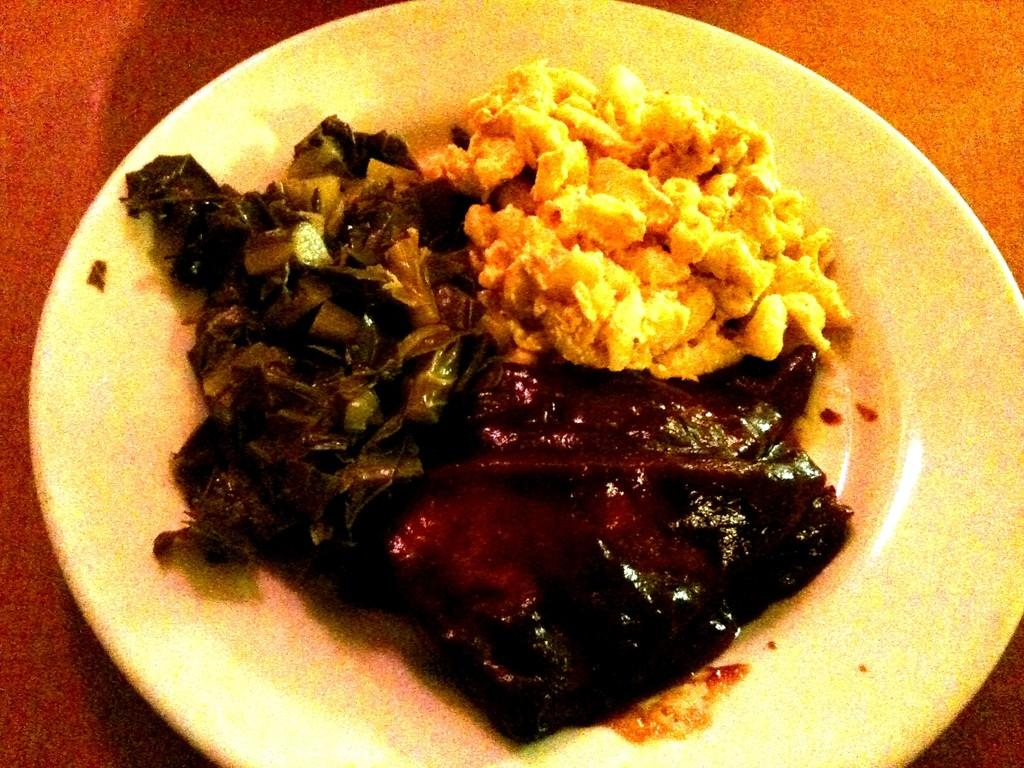What is on the plate that is visible in the image? There is food on a plate in the image. Where is the plate located in the image? The plate is placed on a table in the image. What type of canvas is being used to create the industrial scene in the image? There is no canvas or industrial scene present in the image; it only features a plate of food on a table. How many robins can be seen flying in the image? There are no robins present in the image. 